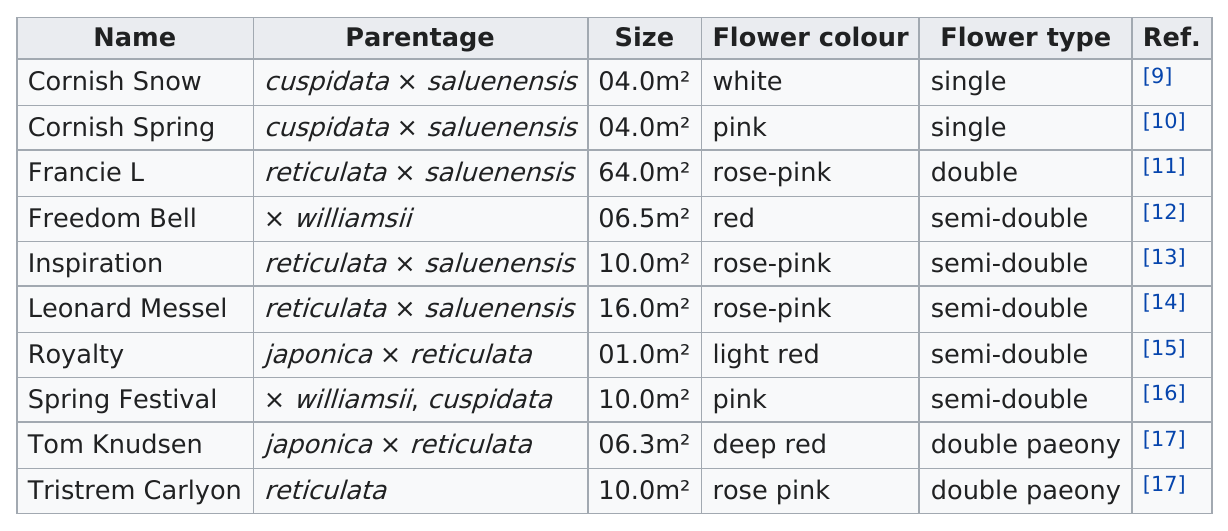Point out several critical features in this image. Cornfish snow and cornfish spring are both 0.4 square meters. There are four cultivars that are the color 'rose-pink.' Of the plants listed, how many have a size of at least 10 square meters? There are five distinct semi-double flower types listed. Leonard Messel is larger in size than royalty. 